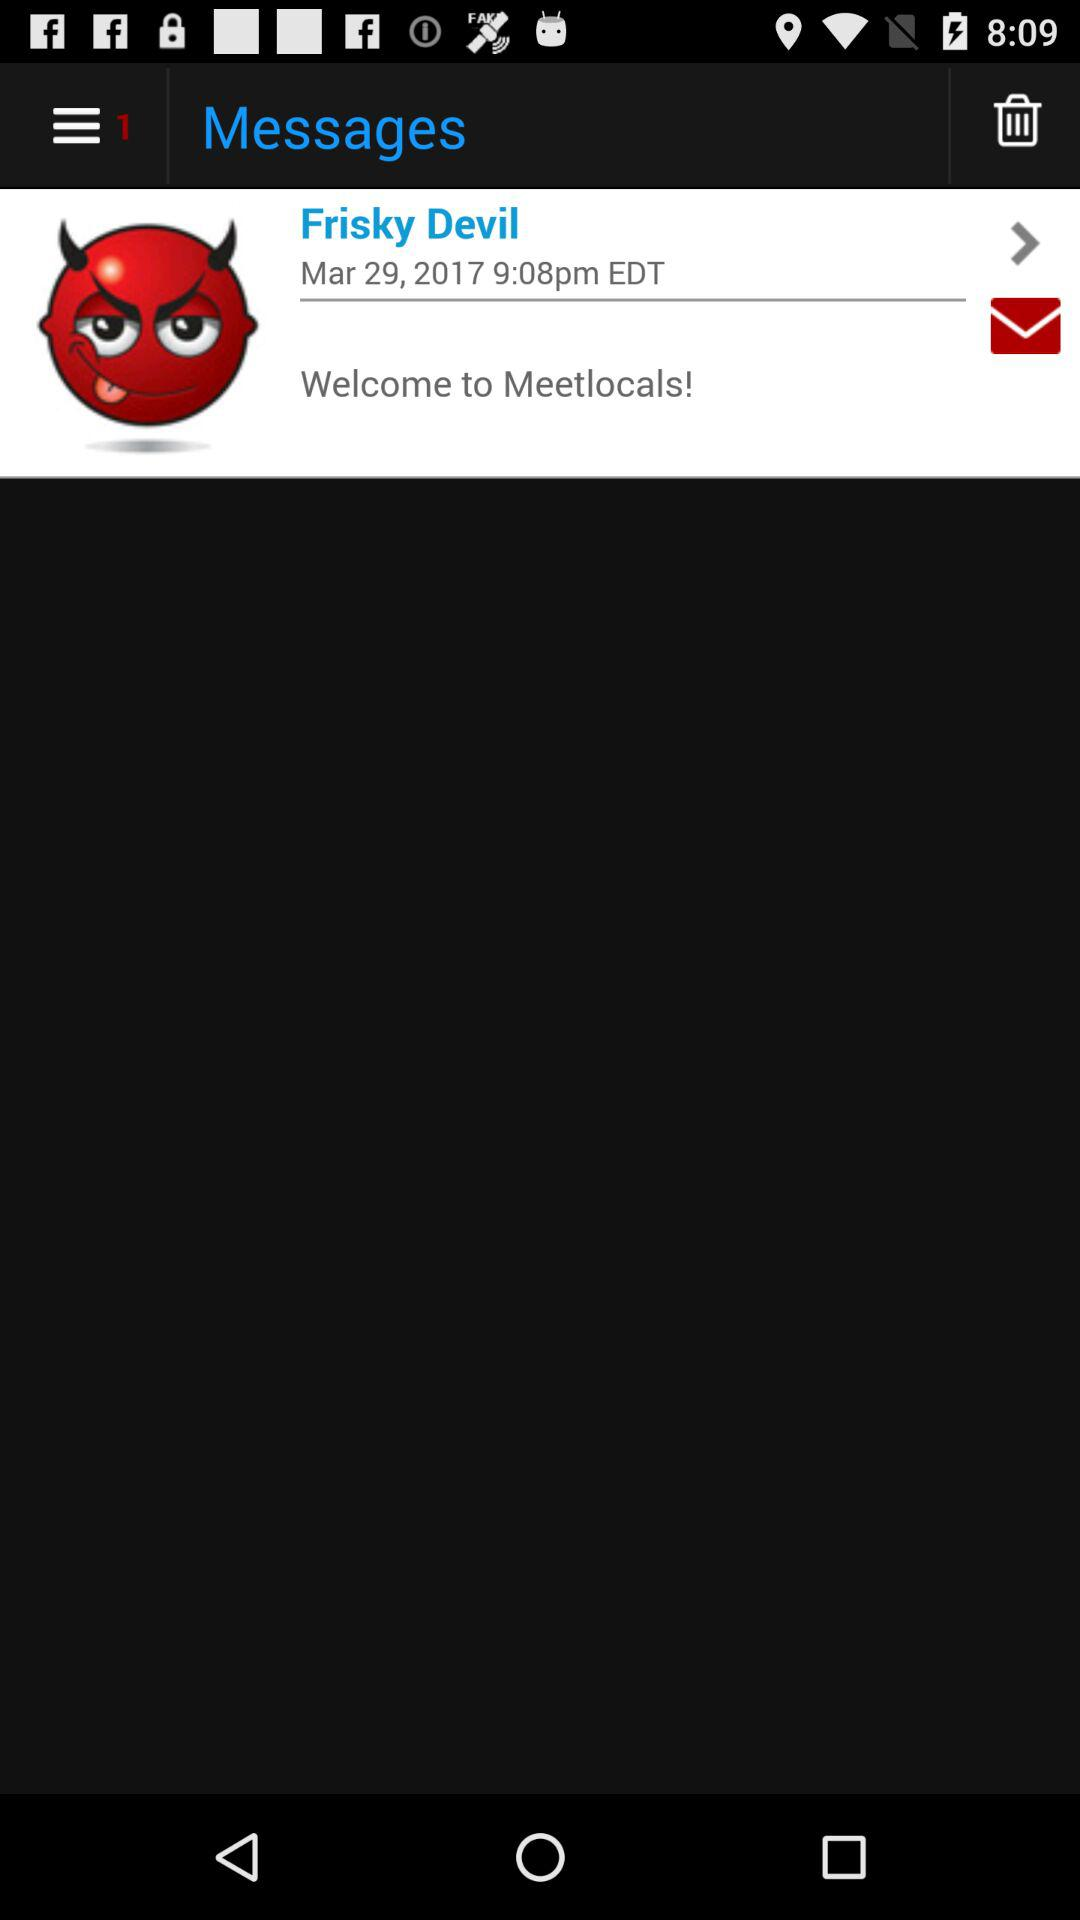Which date and time is selected? The time and date are March 29, 2017 at 9:08pm. 